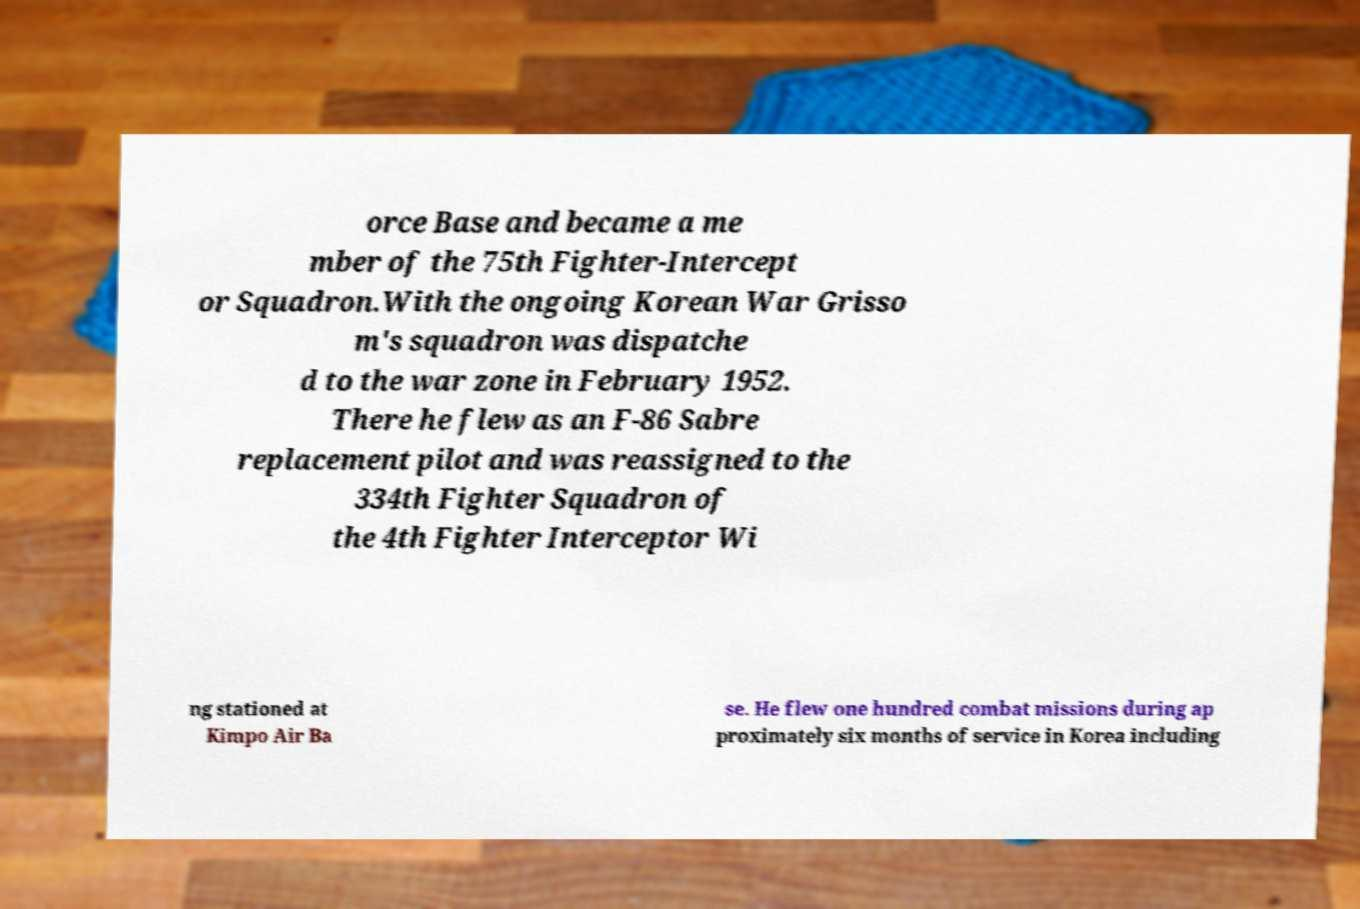For documentation purposes, I need the text within this image transcribed. Could you provide that? orce Base and became a me mber of the 75th Fighter-Intercept or Squadron.With the ongoing Korean War Grisso m's squadron was dispatche d to the war zone in February 1952. There he flew as an F-86 Sabre replacement pilot and was reassigned to the 334th Fighter Squadron of the 4th Fighter Interceptor Wi ng stationed at Kimpo Air Ba se. He flew one hundred combat missions during ap proximately six months of service in Korea including 